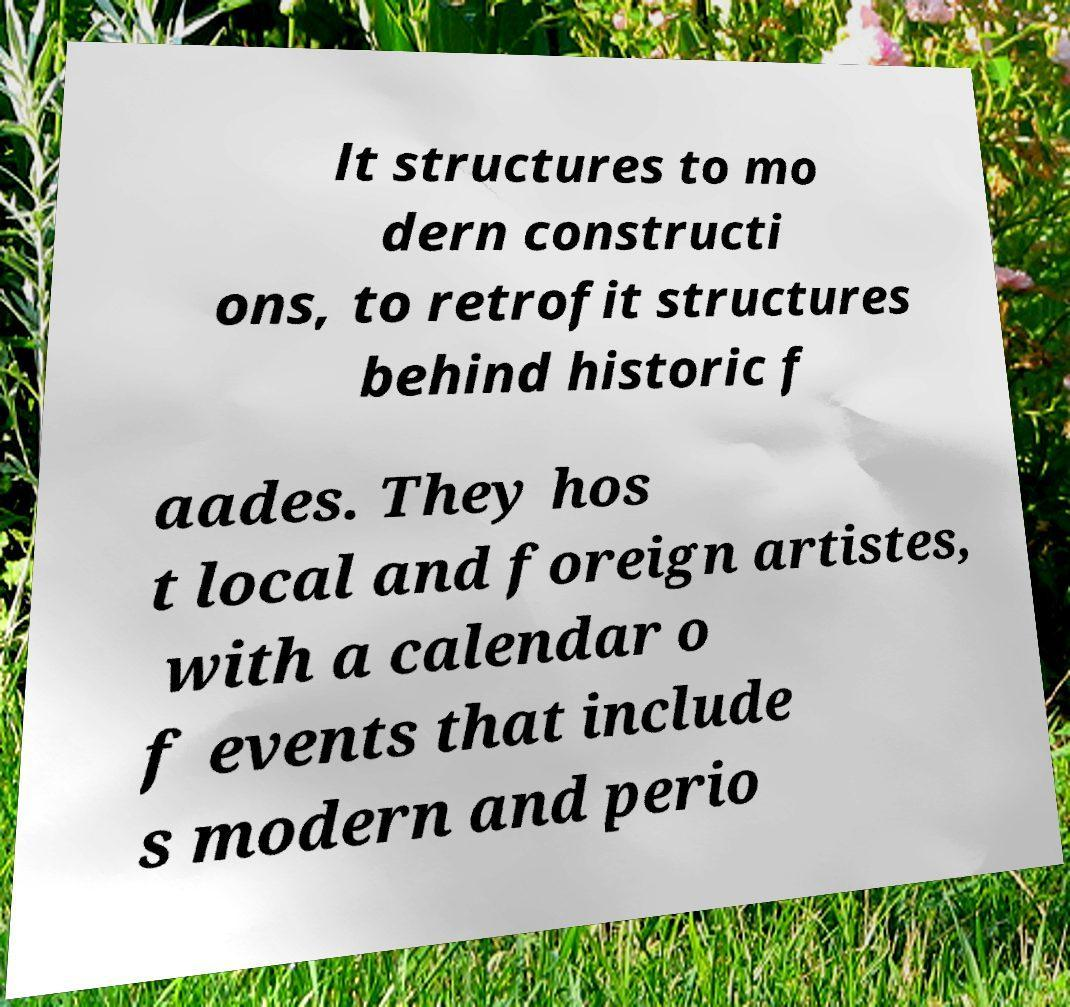Could you extract and type out the text from this image? lt structures to mo dern constructi ons, to retrofit structures behind historic f aades. They hos t local and foreign artistes, with a calendar o f events that include s modern and perio 